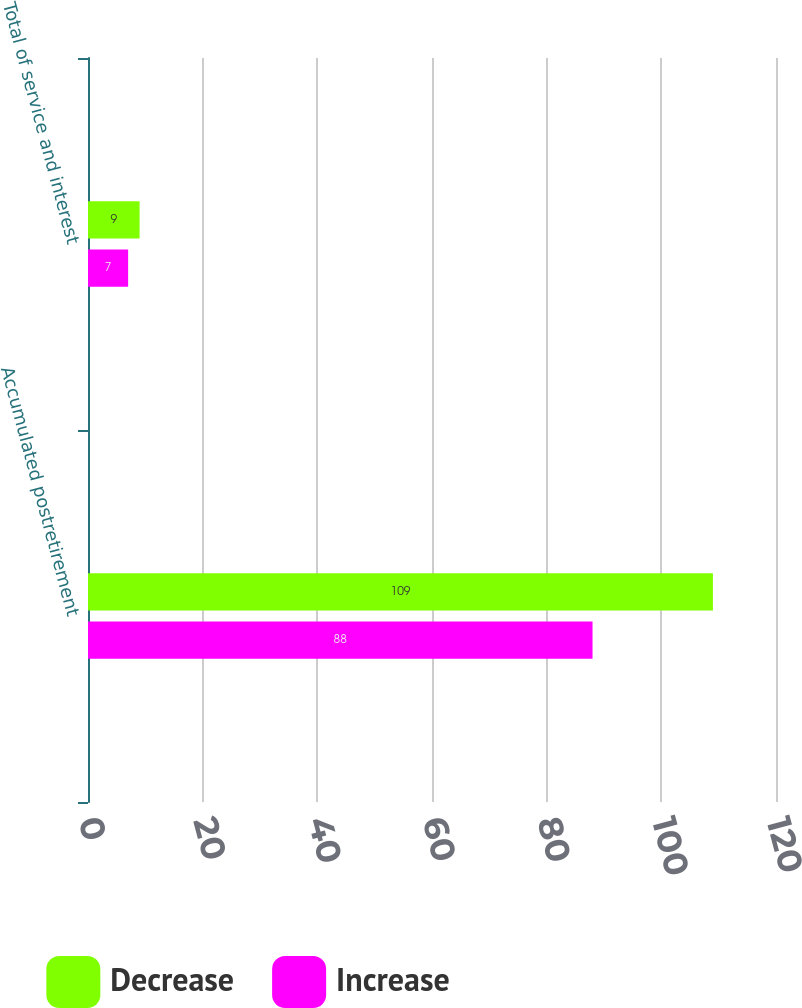<chart> <loc_0><loc_0><loc_500><loc_500><stacked_bar_chart><ecel><fcel>Accumulated postretirement<fcel>Total of service and interest<nl><fcel>Decrease<fcel>109<fcel>9<nl><fcel>Increase<fcel>88<fcel>7<nl></chart> 